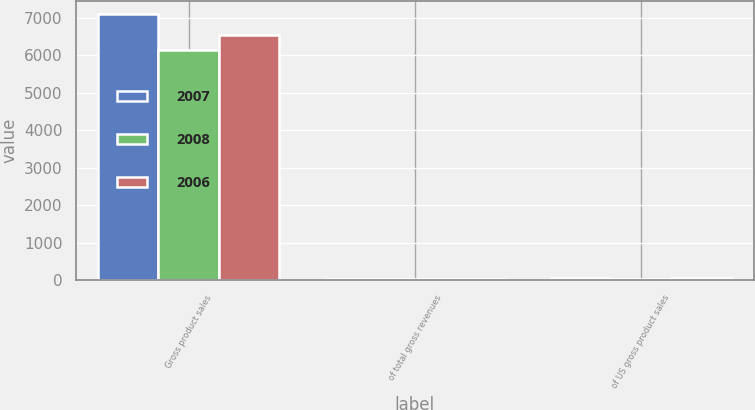<chart> <loc_0><loc_0><loc_500><loc_500><stacked_bar_chart><ecel><fcel>Gross product sales<fcel>of total gross revenues<fcel>of US gross product sales<nl><fcel>2007<fcel>7099<fcel>37<fcel>46<nl><fcel>2008<fcel>6124<fcel>31<fcel>39<nl><fcel>2006<fcel>6523<fcel>35<fcel>42<nl></chart> 